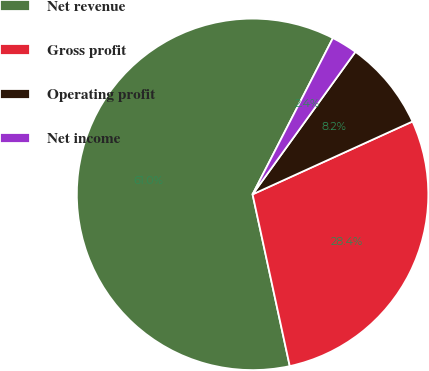Convert chart. <chart><loc_0><loc_0><loc_500><loc_500><pie_chart><fcel>Net revenue<fcel>Gross profit<fcel>Operating profit<fcel>Net income<nl><fcel>60.95%<fcel>28.41%<fcel>8.25%<fcel>2.39%<nl></chart> 